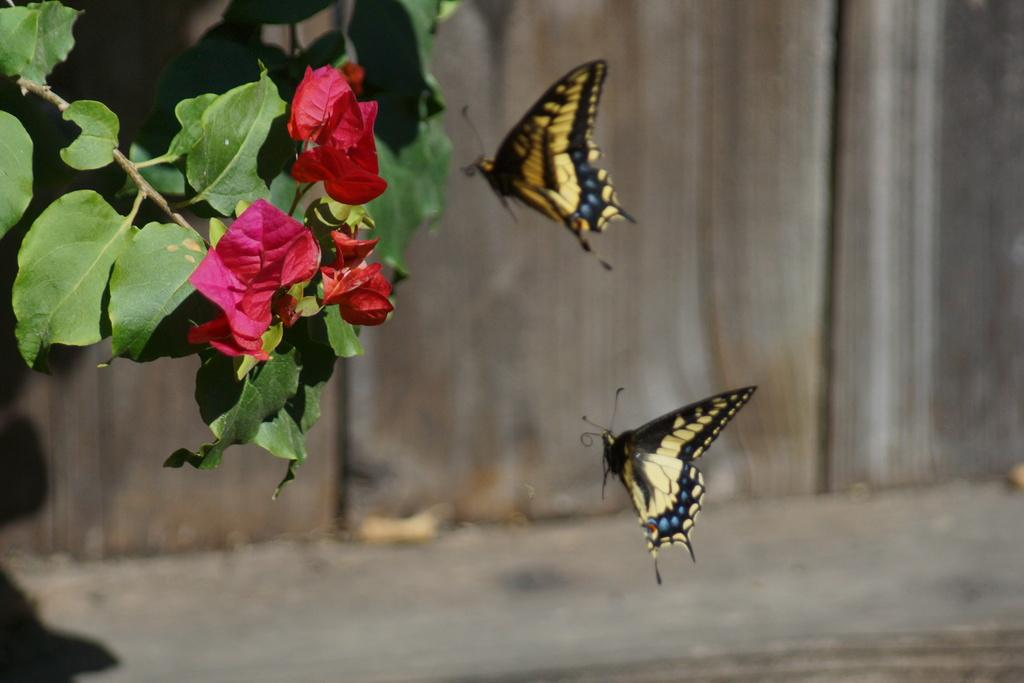What is located in the middle of the image? There are two butterflies in the middle of the image. What can be seen behind the butterflies? There is a wall visible behind the butterflies. What is present in the top left corner of the image? There is a plant and flowers in the top left corner of the image. What type of leather can be seen in the image? There is no leather present in the image. How do the butterflies move in the image? The butterflies are not moving in the image; they are stationary. 